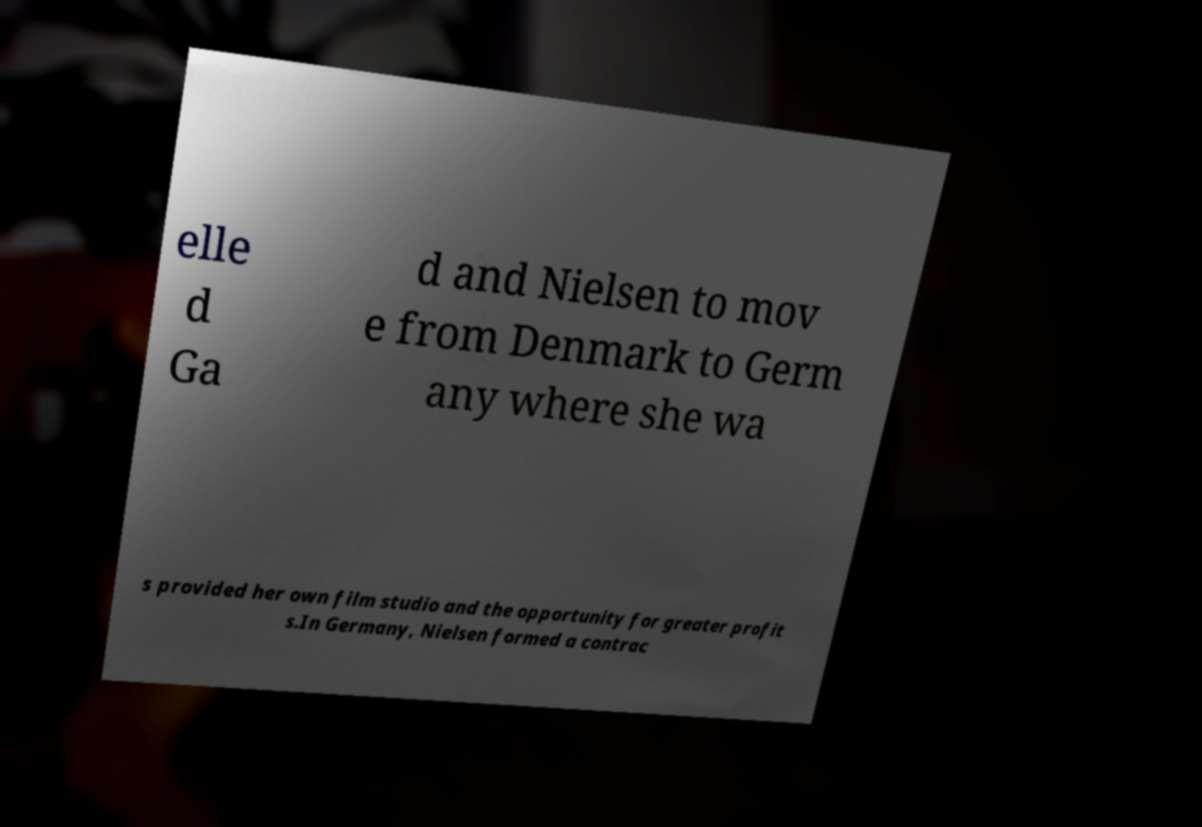Please identify and transcribe the text found in this image. elle d Ga d and Nielsen to mov e from Denmark to Germ any where she wa s provided her own film studio and the opportunity for greater profit s.In Germany, Nielsen formed a contrac 